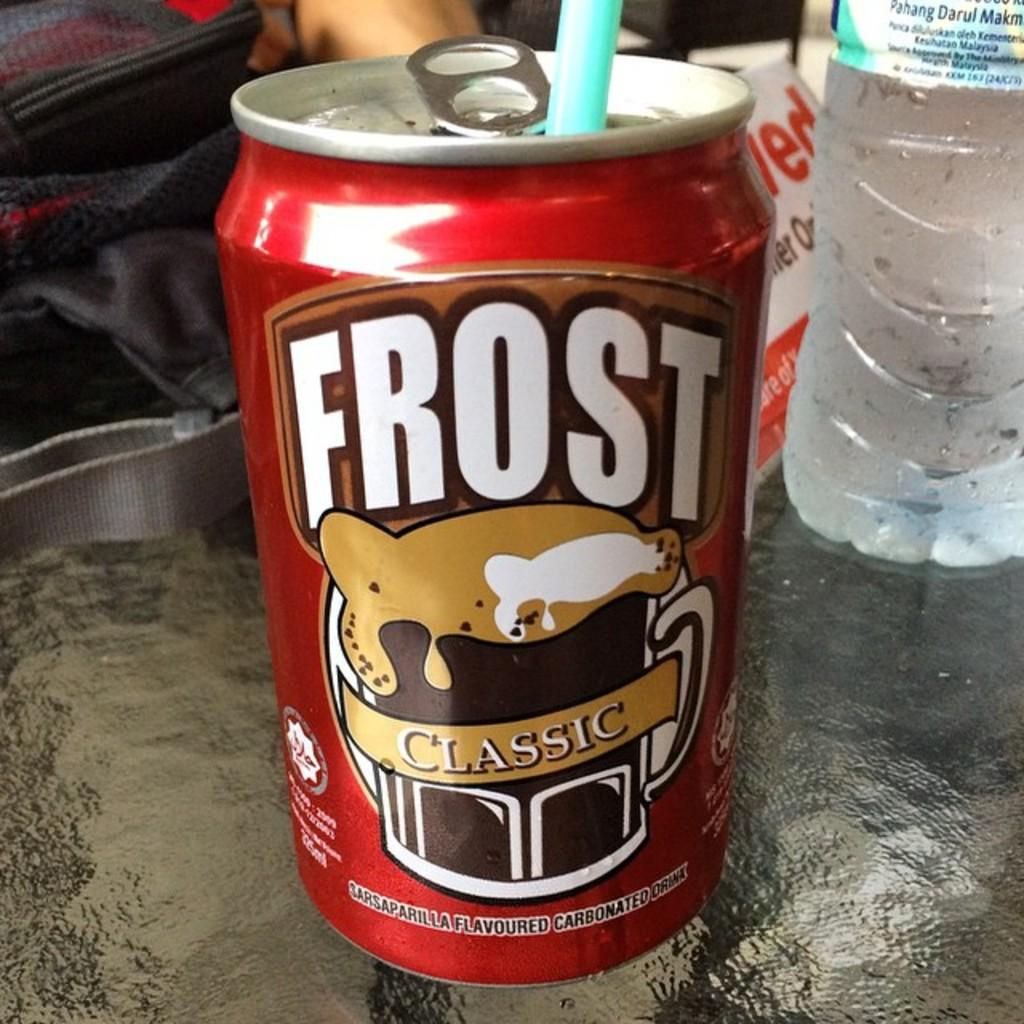Provide a one-sentence caption for the provided image. A straw is in the can of Frost Classic. 